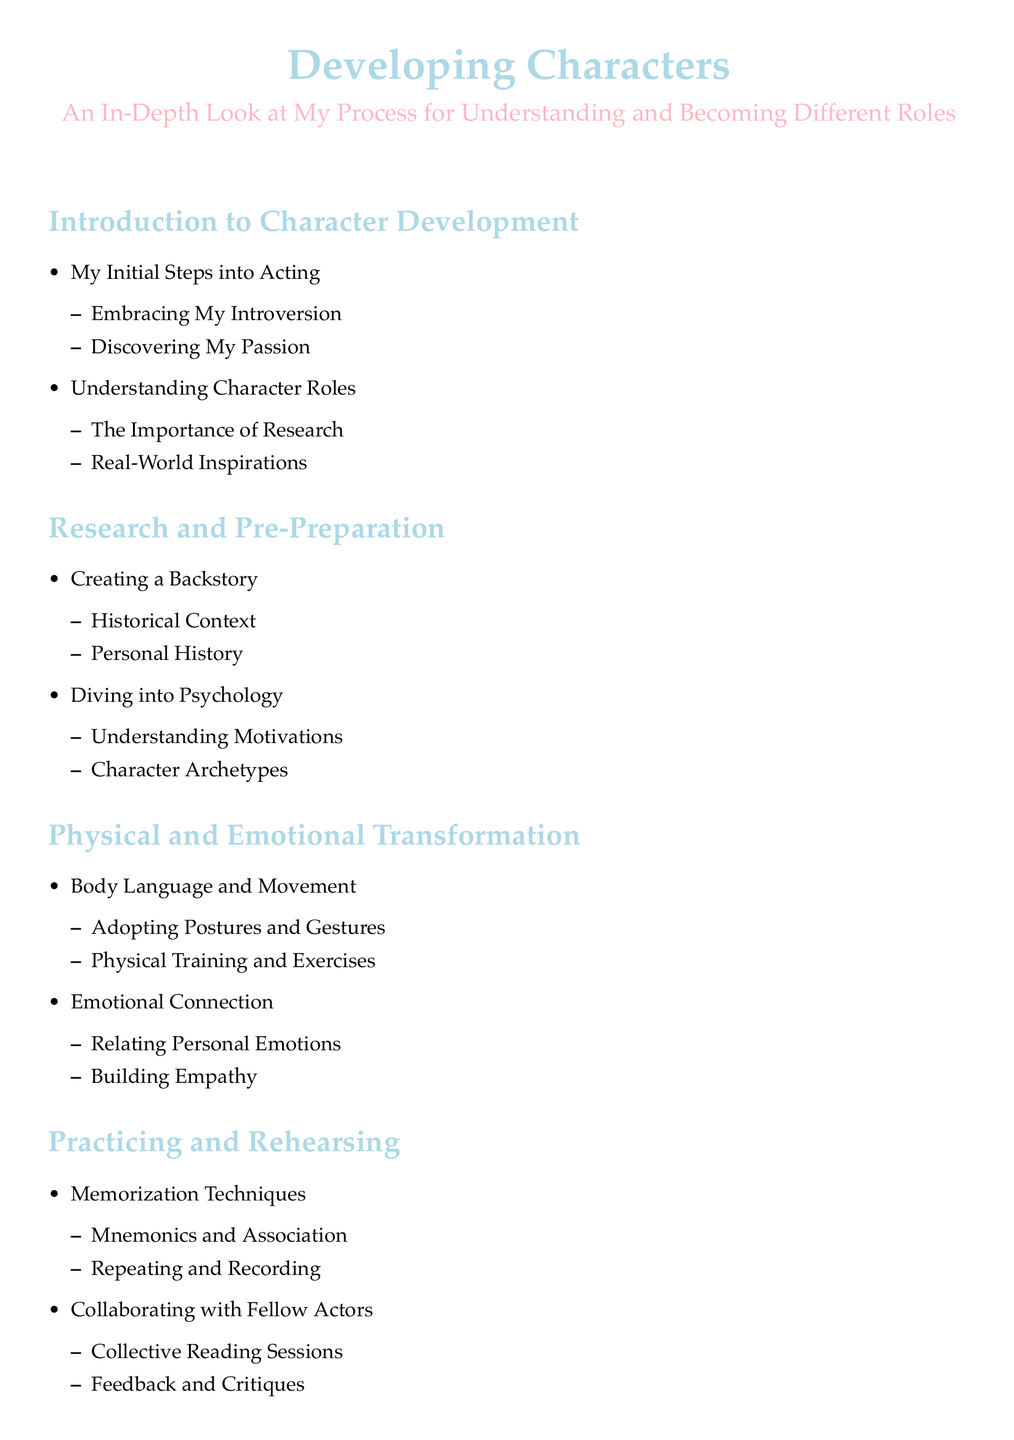What are the main sections of the document? The main sections are the headings outlined in the table of contents, which are Introduction to Character Development, Research and Pre-Preparation, Physical and Emotional Transformation, Practicing and Rehearsing, Performance and Reflection, and Conclusion.
Answer: Introduction to Character Development, Research and Pre-Preparation, Physical and Emotional Transformation, Practicing and Rehearsing, Performance and Reflection, Conclusion What topic is covered in the first subsection of the Introduction? The first subsection under Introduction discusses "Embracing My Introversion," which highlights personal reflection on introversion in the context of acting.
Answer: Embracing My Introversion How many items are there under 'Research and Pre-Preparation'? The section 'Research and Pre-Preparation' includes two main items: Creating a Backstory and Diving into Psychology, thus there are four items in total when counting the subsections as well.
Answer: 4 What does 'Building Empathy' relate to? 'Building Empathy' is listed under the main section 'Physical and Emotional Transformation' and focuses on connecting emotionally to create realistic character portrayals.
Answer: Building Empathy What is the focus of the last item in the Conclusion? The last item in Conclusion summarizes future aspirations or plans regarding developing new roles and indicates ongoing growth in acting skills.
Answer: Plans for Future Roles 